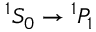<formula> <loc_0><loc_0><loc_500><loc_500>^ { 1 } S _ { 0 } ^ { 1 } P _ { 1 }</formula> 